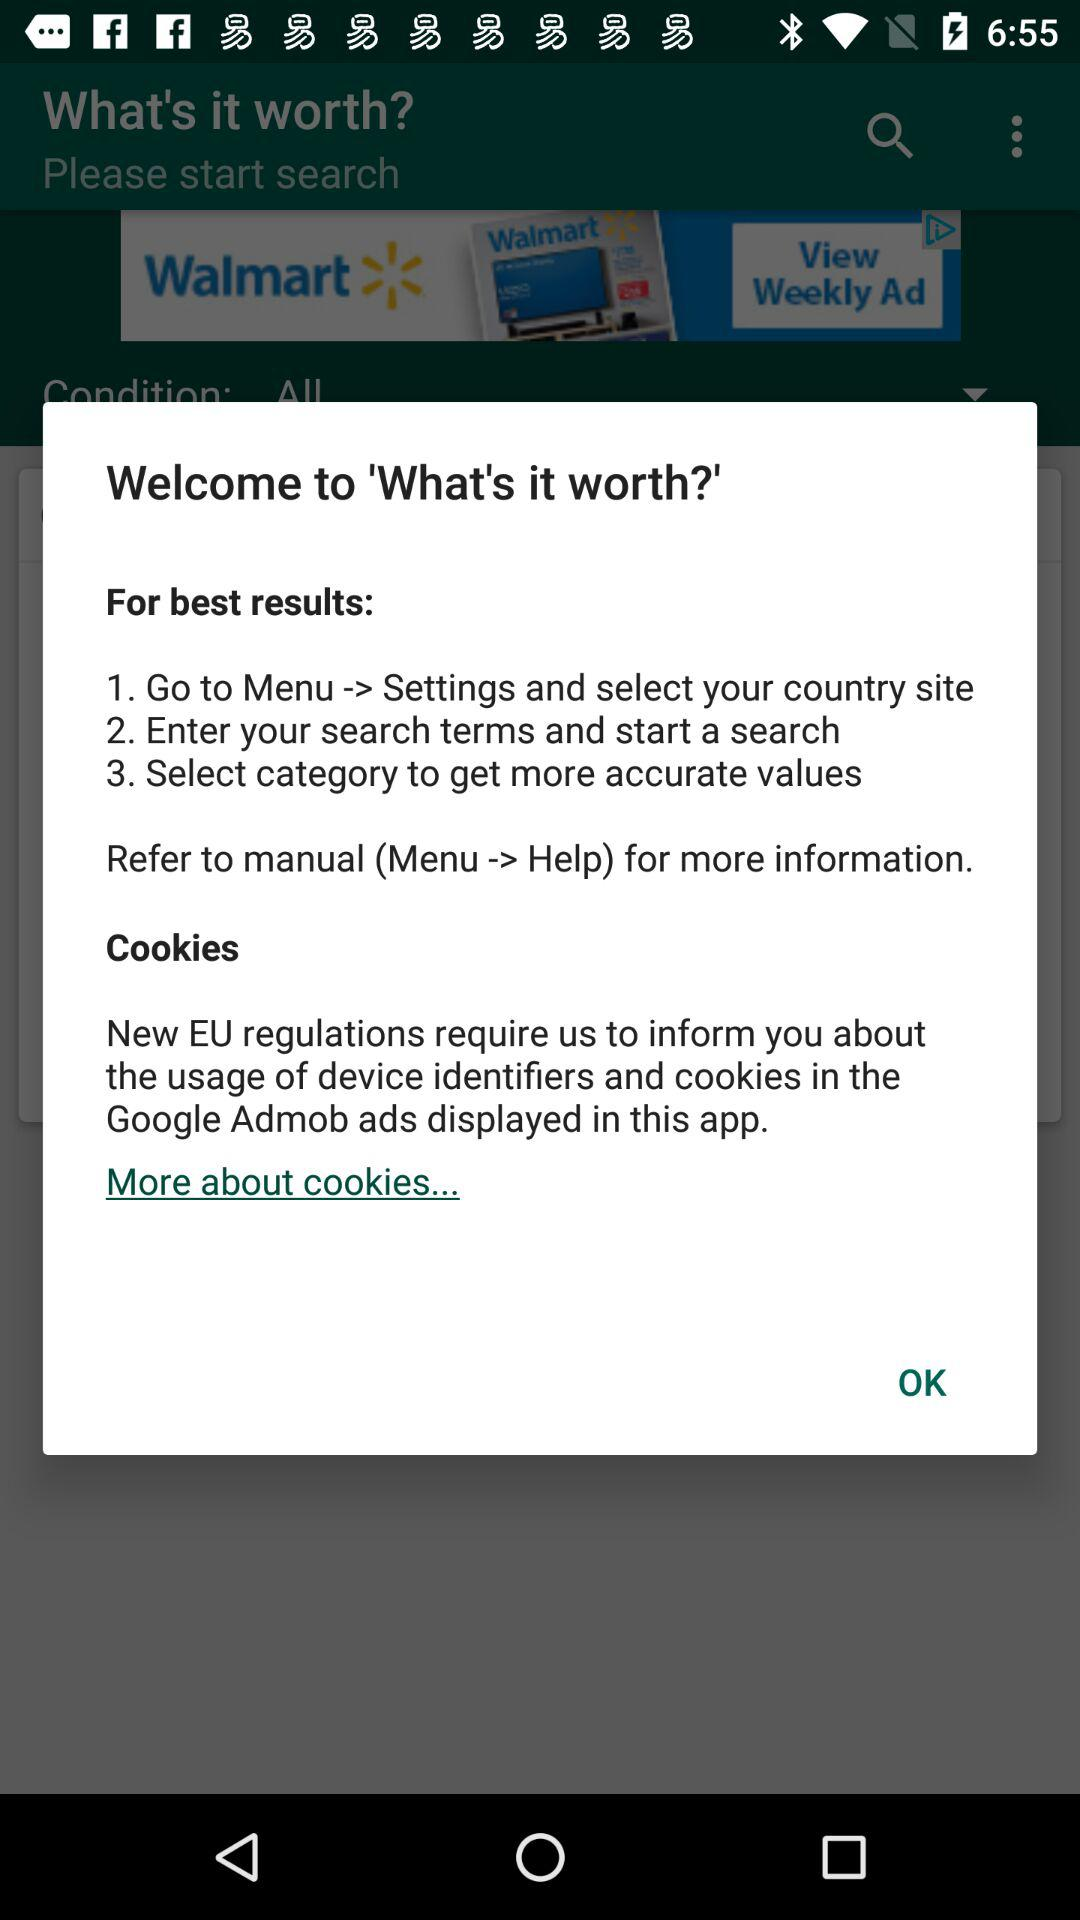How many steps are there in total for getting the best results?
Answer the question using a single word or phrase. 3 